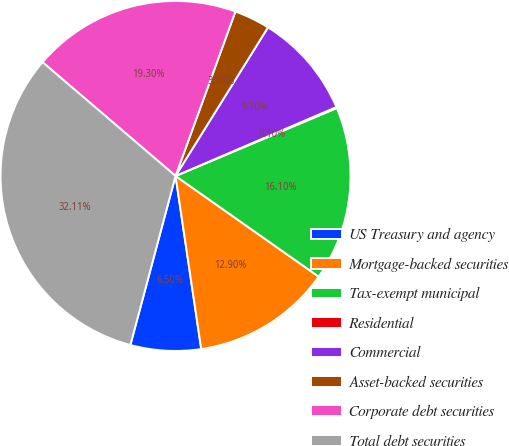<chart> <loc_0><loc_0><loc_500><loc_500><pie_chart><fcel>US Treasury and agency<fcel>Mortgage-backed securities<fcel>Tax-exempt municipal<fcel>Residential<fcel>Commercial<fcel>Asset-backed securities<fcel>Corporate debt securities<fcel>Total debt securities<nl><fcel>6.5%<fcel>12.9%<fcel>16.1%<fcel>0.1%<fcel>9.7%<fcel>3.3%<fcel>19.3%<fcel>32.11%<nl></chart> 